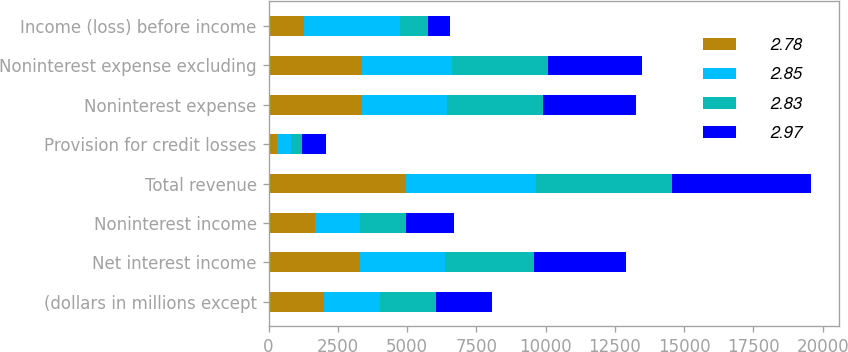Convert chart. <chart><loc_0><loc_0><loc_500><loc_500><stacked_bar_chart><ecel><fcel>(dollars in millions except<fcel>Net interest income<fcel>Noninterest income<fcel>Total revenue<fcel>Provision for credit losses<fcel>Noninterest expense<fcel>Noninterest expense excluding<fcel>Income (loss) before income<nl><fcel>2.78<fcel>2014<fcel>3301<fcel>1678<fcel>4979<fcel>319<fcel>3392<fcel>3392<fcel>1268<nl><fcel>2.85<fcel>2013<fcel>3058<fcel>1632<fcel>4690<fcel>479<fcel>3058<fcel>3244<fcel>3468<nl><fcel>2.83<fcel>2012<fcel>3227<fcel>1667<fcel>4894<fcel>413<fcel>3457<fcel>3457<fcel>1024<nl><fcel>2.97<fcel>2011<fcel>3320<fcel>1711<fcel>5031<fcel>882<fcel>3371<fcel>3371<fcel>778<nl></chart> 